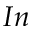<formula> <loc_0><loc_0><loc_500><loc_500>I n</formula> 